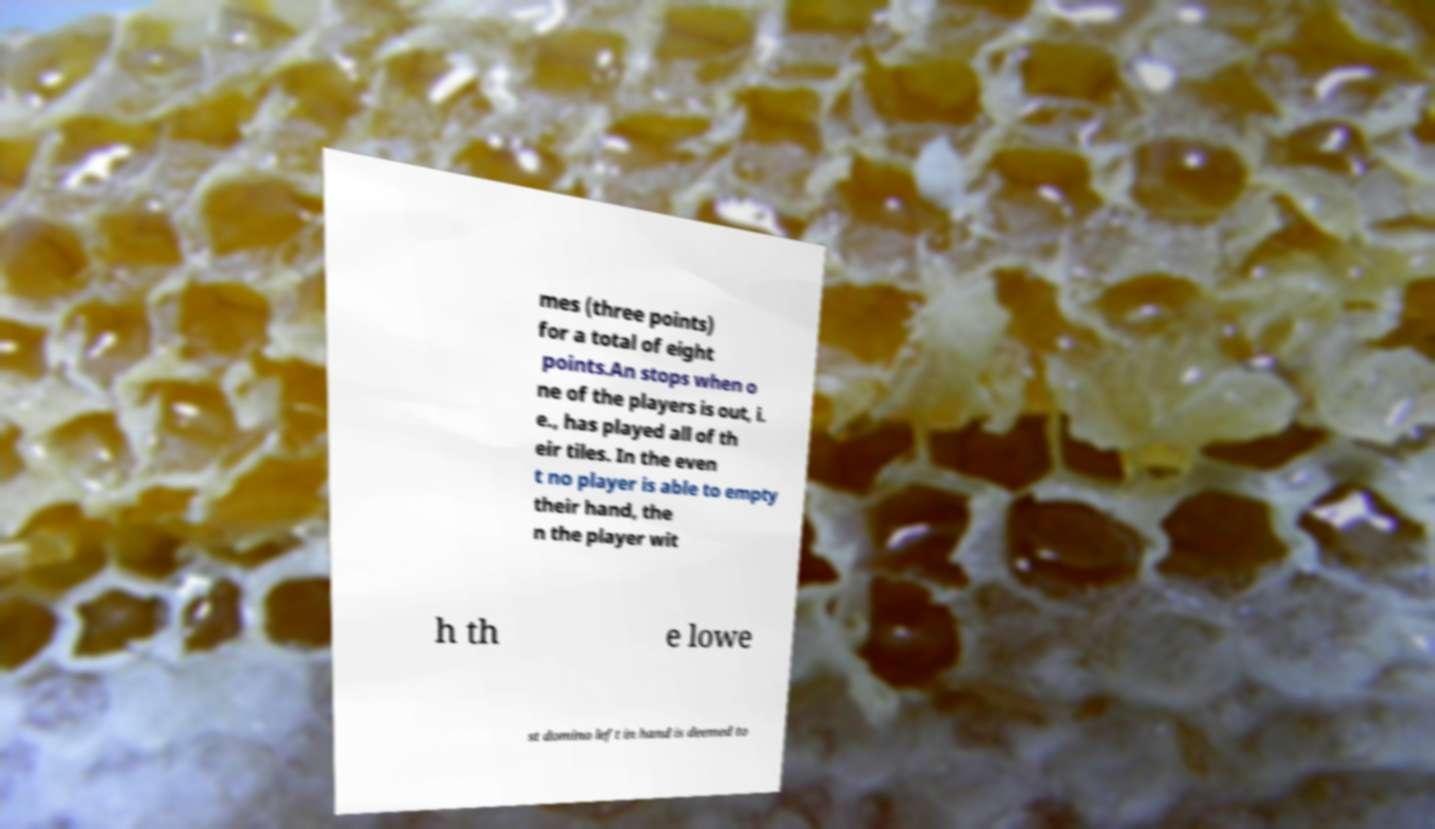Can you read and provide the text displayed in the image?This photo seems to have some interesting text. Can you extract and type it out for me? mes (three points) for a total of eight points.An stops when o ne of the players is out, i. e., has played all of th eir tiles. In the even t no player is able to empty their hand, the n the player wit h th e lowe st domino left in hand is deemed to 